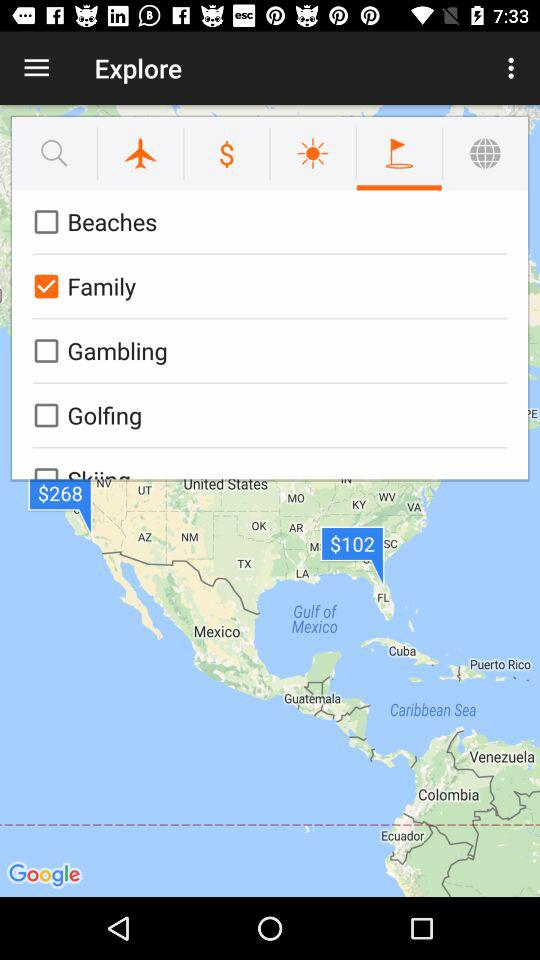What is the status of "Family"? The status is "on". 